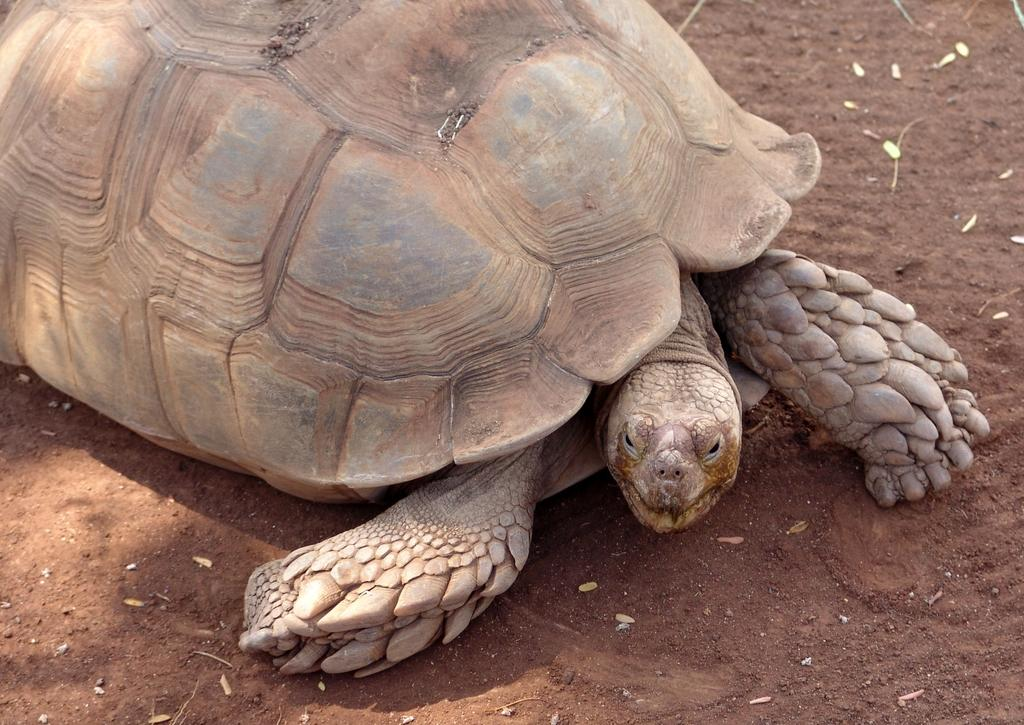Where was the image taken? The image was taken outdoors. What can be seen under the tortoise in the image? There is a ground visible in the image. What type of animal is present in the image? There is a tortoise on the ground in the image. What type of fang can be seen in the image? There is no fang present in the image; it features a tortoise on the ground. What type of love is being expressed by the tortoise in the image? Tortoises do not express love in the same way as humans or other animals, so it is not possible to determine any expression of love in the image. 